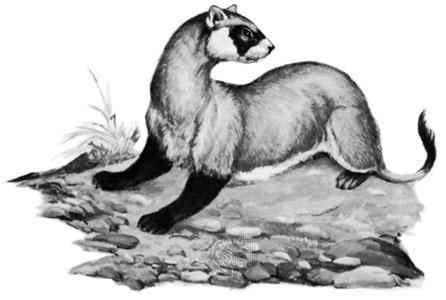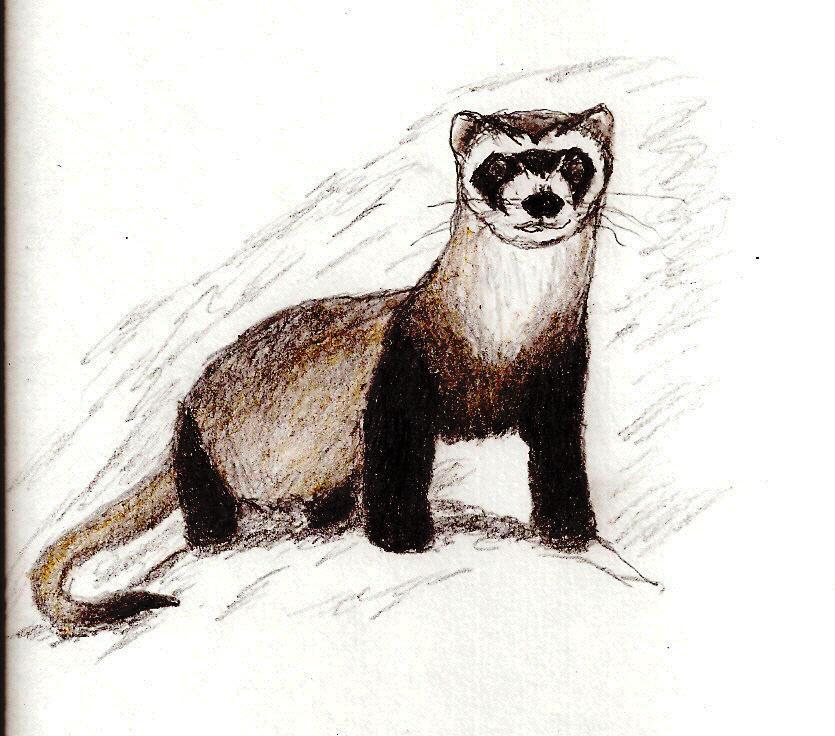The first image is the image on the left, the second image is the image on the right. For the images shown, is this caption "The animal in one of the images is situated in the grass." true? Answer yes or no. No. The first image is the image on the left, the second image is the image on the right. For the images displayed, is the sentence "there is a ferret in tall grass" factually correct? Answer yes or no. No. 